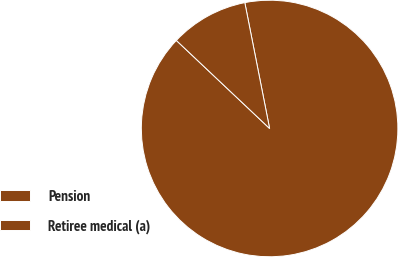Convert chart. <chart><loc_0><loc_0><loc_500><loc_500><pie_chart><fcel>Pension<fcel>Retiree medical (a)<nl><fcel>90.14%<fcel>9.86%<nl></chart> 